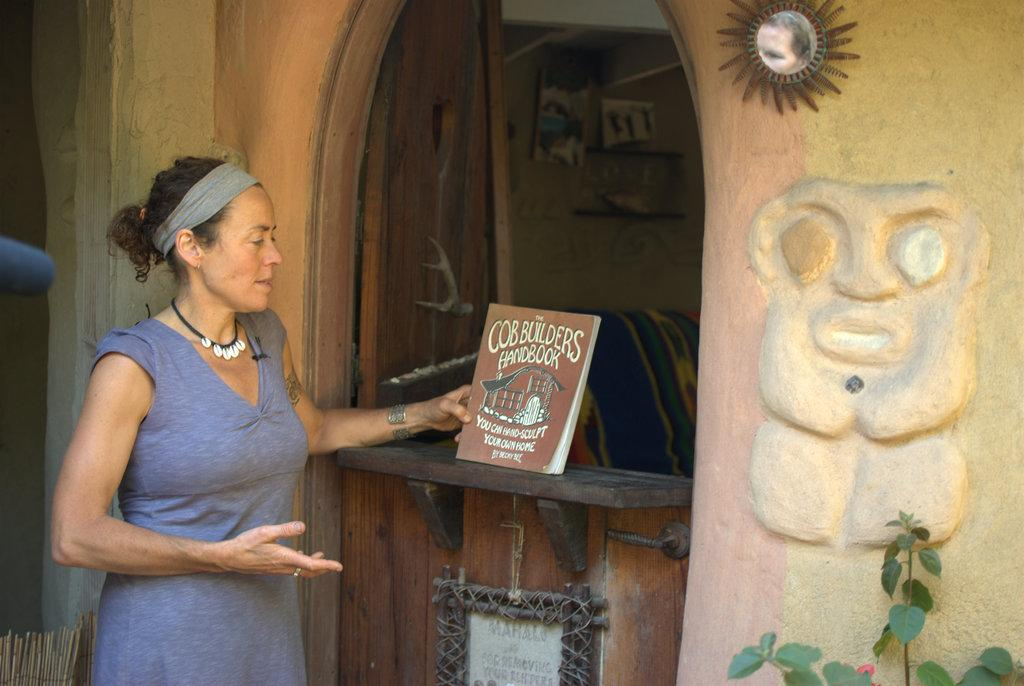What is the woman on the left side of the image doing? The woman is holding a book. Can you describe any other objects or features in the image? Yes, there is a plant in the bottom right hand corner of the image, and there is a frame on the wall at the top of the image. What type of impulse can be seen in the image? There is no impulse present in the image. 